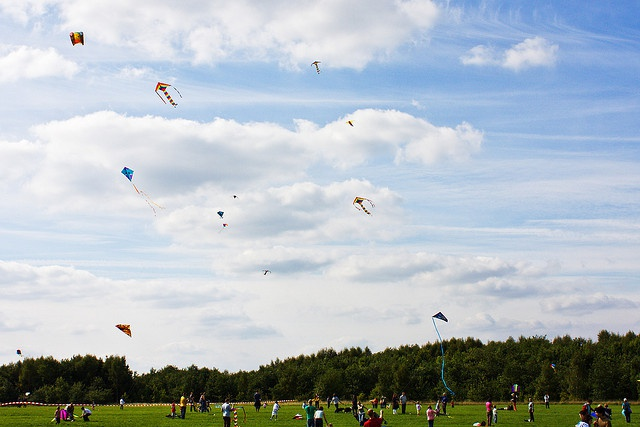Describe the objects in this image and their specific colors. I can see people in white, black, olive, darkgreen, and maroon tones, kite in white, black, olive, lightgray, and darkgreen tones, kite in white, lightgray, lightblue, teal, and pink tones, kite in white, red, lightblue, and darkgray tones, and people in white, black, maroon, brown, and darkgreen tones in this image. 